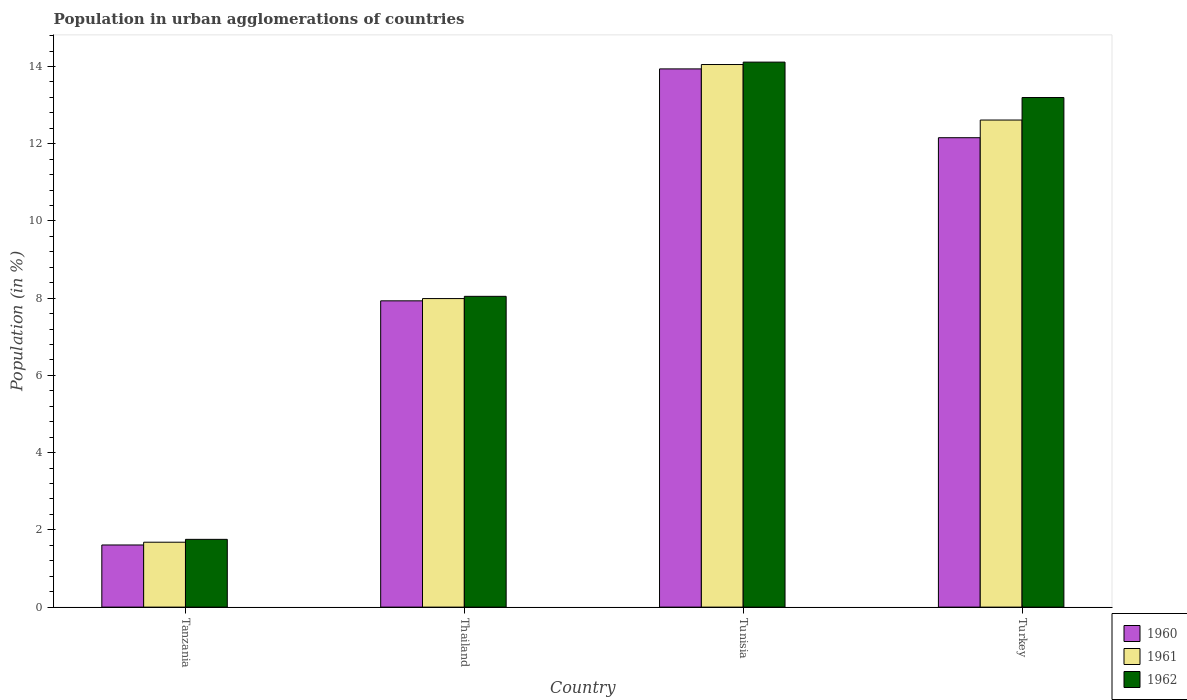How many different coloured bars are there?
Give a very brief answer. 3. How many groups of bars are there?
Provide a succinct answer. 4. Are the number of bars per tick equal to the number of legend labels?
Your answer should be very brief. Yes. What is the label of the 2nd group of bars from the left?
Offer a very short reply. Thailand. In how many cases, is the number of bars for a given country not equal to the number of legend labels?
Provide a short and direct response. 0. What is the percentage of population in urban agglomerations in 1960 in Tunisia?
Ensure brevity in your answer.  13.94. Across all countries, what is the maximum percentage of population in urban agglomerations in 1961?
Give a very brief answer. 14.05. Across all countries, what is the minimum percentage of population in urban agglomerations in 1960?
Provide a short and direct response. 1.61. In which country was the percentage of population in urban agglomerations in 1962 maximum?
Give a very brief answer. Tunisia. In which country was the percentage of population in urban agglomerations in 1961 minimum?
Your answer should be very brief. Tanzania. What is the total percentage of population in urban agglomerations in 1961 in the graph?
Provide a short and direct response. 36.34. What is the difference between the percentage of population in urban agglomerations in 1962 in Tanzania and that in Turkey?
Your answer should be compact. -11.44. What is the difference between the percentage of population in urban agglomerations in 1961 in Tanzania and the percentage of population in urban agglomerations in 1960 in Tunisia?
Keep it short and to the point. -12.26. What is the average percentage of population in urban agglomerations in 1961 per country?
Make the answer very short. 9.08. What is the difference between the percentage of population in urban agglomerations of/in 1961 and percentage of population in urban agglomerations of/in 1960 in Thailand?
Your response must be concise. 0.06. What is the ratio of the percentage of population in urban agglomerations in 1960 in Tanzania to that in Turkey?
Provide a succinct answer. 0.13. Is the percentage of population in urban agglomerations in 1960 in Thailand less than that in Tunisia?
Offer a terse response. Yes. What is the difference between the highest and the second highest percentage of population in urban agglomerations in 1960?
Keep it short and to the point. -1.78. What is the difference between the highest and the lowest percentage of population in urban agglomerations in 1962?
Give a very brief answer. 12.36. What does the 3rd bar from the left in Turkey represents?
Provide a succinct answer. 1962. Is it the case that in every country, the sum of the percentage of population in urban agglomerations in 1961 and percentage of population in urban agglomerations in 1962 is greater than the percentage of population in urban agglomerations in 1960?
Give a very brief answer. Yes. How many bars are there?
Your answer should be compact. 12. Are all the bars in the graph horizontal?
Your answer should be compact. No. Does the graph contain any zero values?
Offer a terse response. No. Does the graph contain grids?
Give a very brief answer. No. Where does the legend appear in the graph?
Make the answer very short. Bottom right. How many legend labels are there?
Make the answer very short. 3. What is the title of the graph?
Make the answer very short. Population in urban agglomerations of countries. What is the label or title of the X-axis?
Your answer should be very brief. Country. What is the Population (in %) in 1960 in Tanzania?
Provide a short and direct response. 1.61. What is the Population (in %) in 1961 in Tanzania?
Offer a very short reply. 1.68. What is the Population (in %) of 1962 in Tanzania?
Your response must be concise. 1.76. What is the Population (in %) of 1960 in Thailand?
Ensure brevity in your answer.  7.93. What is the Population (in %) in 1961 in Thailand?
Your answer should be very brief. 7.99. What is the Population (in %) of 1962 in Thailand?
Your response must be concise. 8.05. What is the Population (in %) of 1960 in Tunisia?
Your answer should be compact. 13.94. What is the Population (in %) in 1961 in Tunisia?
Keep it short and to the point. 14.05. What is the Population (in %) of 1962 in Tunisia?
Give a very brief answer. 14.11. What is the Population (in %) in 1960 in Turkey?
Your answer should be very brief. 12.16. What is the Population (in %) of 1961 in Turkey?
Keep it short and to the point. 12.61. What is the Population (in %) of 1962 in Turkey?
Give a very brief answer. 13.2. Across all countries, what is the maximum Population (in %) of 1960?
Your answer should be very brief. 13.94. Across all countries, what is the maximum Population (in %) of 1961?
Keep it short and to the point. 14.05. Across all countries, what is the maximum Population (in %) of 1962?
Offer a very short reply. 14.11. Across all countries, what is the minimum Population (in %) of 1960?
Your answer should be compact. 1.61. Across all countries, what is the minimum Population (in %) in 1961?
Offer a very short reply. 1.68. Across all countries, what is the minimum Population (in %) in 1962?
Make the answer very short. 1.76. What is the total Population (in %) of 1960 in the graph?
Offer a very short reply. 35.63. What is the total Population (in %) in 1961 in the graph?
Offer a terse response. 36.34. What is the total Population (in %) of 1962 in the graph?
Ensure brevity in your answer.  37.11. What is the difference between the Population (in %) in 1960 in Tanzania and that in Thailand?
Your response must be concise. -6.32. What is the difference between the Population (in %) of 1961 in Tanzania and that in Thailand?
Your answer should be compact. -6.31. What is the difference between the Population (in %) of 1962 in Tanzania and that in Thailand?
Provide a short and direct response. -6.29. What is the difference between the Population (in %) in 1960 in Tanzania and that in Tunisia?
Provide a succinct answer. -12.33. What is the difference between the Population (in %) in 1961 in Tanzania and that in Tunisia?
Offer a terse response. -12.37. What is the difference between the Population (in %) of 1962 in Tanzania and that in Tunisia?
Provide a succinct answer. -12.36. What is the difference between the Population (in %) in 1960 in Tanzania and that in Turkey?
Offer a terse response. -10.55. What is the difference between the Population (in %) in 1961 in Tanzania and that in Turkey?
Your answer should be very brief. -10.93. What is the difference between the Population (in %) in 1962 in Tanzania and that in Turkey?
Your response must be concise. -11.44. What is the difference between the Population (in %) of 1960 in Thailand and that in Tunisia?
Your answer should be compact. -6.01. What is the difference between the Population (in %) in 1961 in Thailand and that in Tunisia?
Your response must be concise. -6.06. What is the difference between the Population (in %) of 1962 in Thailand and that in Tunisia?
Offer a very short reply. -6.07. What is the difference between the Population (in %) in 1960 in Thailand and that in Turkey?
Give a very brief answer. -4.22. What is the difference between the Population (in %) of 1961 in Thailand and that in Turkey?
Your response must be concise. -4.62. What is the difference between the Population (in %) in 1962 in Thailand and that in Turkey?
Offer a very short reply. -5.15. What is the difference between the Population (in %) in 1960 in Tunisia and that in Turkey?
Your answer should be very brief. 1.78. What is the difference between the Population (in %) in 1961 in Tunisia and that in Turkey?
Offer a very short reply. 1.44. What is the difference between the Population (in %) in 1960 in Tanzania and the Population (in %) in 1961 in Thailand?
Make the answer very short. -6.38. What is the difference between the Population (in %) in 1960 in Tanzania and the Population (in %) in 1962 in Thailand?
Your answer should be compact. -6.44. What is the difference between the Population (in %) of 1961 in Tanzania and the Population (in %) of 1962 in Thailand?
Offer a terse response. -6.37. What is the difference between the Population (in %) in 1960 in Tanzania and the Population (in %) in 1961 in Tunisia?
Ensure brevity in your answer.  -12.44. What is the difference between the Population (in %) in 1960 in Tanzania and the Population (in %) in 1962 in Tunisia?
Make the answer very short. -12.5. What is the difference between the Population (in %) in 1961 in Tanzania and the Population (in %) in 1962 in Tunisia?
Your response must be concise. -12.43. What is the difference between the Population (in %) in 1960 in Tanzania and the Population (in %) in 1961 in Turkey?
Your answer should be very brief. -11. What is the difference between the Population (in %) in 1960 in Tanzania and the Population (in %) in 1962 in Turkey?
Provide a short and direct response. -11.59. What is the difference between the Population (in %) of 1961 in Tanzania and the Population (in %) of 1962 in Turkey?
Ensure brevity in your answer.  -11.52. What is the difference between the Population (in %) in 1960 in Thailand and the Population (in %) in 1961 in Tunisia?
Your answer should be compact. -6.12. What is the difference between the Population (in %) of 1960 in Thailand and the Population (in %) of 1962 in Tunisia?
Your answer should be very brief. -6.18. What is the difference between the Population (in %) of 1961 in Thailand and the Population (in %) of 1962 in Tunisia?
Provide a short and direct response. -6.12. What is the difference between the Population (in %) in 1960 in Thailand and the Population (in %) in 1961 in Turkey?
Make the answer very short. -4.68. What is the difference between the Population (in %) in 1960 in Thailand and the Population (in %) in 1962 in Turkey?
Your answer should be compact. -5.27. What is the difference between the Population (in %) of 1961 in Thailand and the Population (in %) of 1962 in Turkey?
Keep it short and to the point. -5.21. What is the difference between the Population (in %) in 1960 in Tunisia and the Population (in %) in 1961 in Turkey?
Your answer should be compact. 1.32. What is the difference between the Population (in %) in 1960 in Tunisia and the Population (in %) in 1962 in Turkey?
Your answer should be very brief. 0.74. What is the difference between the Population (in %) of 1961 in Tunisia and the Population (in %) of 1962 in Turkey?
Provide a succinct answer. 0.85. What is the average Population (in %) in 1960 per country?
Offer a very short reply. 8.91. What is the average Population (in %) of 1961 per country?
Provide a succinct answer. 9.08. What is the average Population (in %) of 1962 per country?
Provide a short and direct response. 9.28. What is the difference between the Population (in %) in 1960 and Population (in %) in 1961 in Tanzania?
Offer a terse response. -0.07. What is the difference between the Population (in %) of 1960 and Population (in %) of 1962 in Tanzania?
Provide a short and direct response. -0.15. What is the difference between the Population (in %) of 1961 and Population (in %) of 1962 in Tanzania?
Offer a very short reply. -0.07. What is the difference between the Population (in %) of 1960 and Population (in %) of 1961 in Thailand?
Ensure brevity in your answer.  -0.06. What is the difference between the Population (in %) in 1960 and Population (in %) in 1962 in Thailand?
Give a very brief answer. -0.12. What is the difference between the Population (in %) of 1961 and Population (in %) of 1962 in Thailand?
Make the answer very short. -0.06. What is the difference between the Population (in %) in 1960 and Population (in %) in 1961 in Tunisia?
Make the answer very short. -0.11. What is the difference between the Population (in %) of 1960 and Population (in %) of 1962 in Tunisia?
Keep it short and to the point. -0.18. What is the difference between the Population (in %) in 1961 and Population (in %) in 1962 in Tunisia?
Provide a short and direct response. -0.06. What is the difference between the Population (in %) of 1960 and Population (in %) of 1961 in Turkey?
Your response must be concise. -0.46. What is the difference between the Population (in %) in 1960 and Population (in %) in 1962 in Turkey?
Your answer should be compact. -1.04. What is the difference between the Population (in %) in 1961 and Population (in %) in 1962 in Turkey?
Provide a short and direct response. -0.58. What is the ratio of the Population (in %) of 1960 in Tanzania to that in Thailand?
Provide a succinct answer. 0.2. What is the ratio of the Population (in %) of 1961 in Tanzania to that in Thailand?
Provide a short and direct response. 0.21. What is the ratio of the Population (in %) in 1962 in Tanzania to that in Thailand?
Your answer should be compact. 0.22. What is the ratio of the Population (in %) in 1960 in Tanzania to that in Tunisia?
Offer a very short reply. 0.12. What is the ratio of the Population (in %) of 1961 in Tanzania to that in Tunisia?
Your answer should be very brief. 0.12. What is the ratio of the Population (in %) in 1962 in Tanzania to that in Tunisia?
Provide a short and direct response. 0.12. What is the ratio of the Population (in %) in 1960 in Tanzania to that in Turkey?
Your answer should be compact. 0.13. What is the ratio of the Population (in %) in 1961 in Tanzania to that in Turkey?
Your answer should be compact. 0.13. What is the ratio of the Population (in %) of 1962 in Tanzania to that in Turkey?
Offer a very short reply. 0.13. What is the ratio of the Population (in %) of 1960 in Thailand to that in Tunisia?
Offer a terse response. 0.57. What is the ratio of the Population (in %) in 1961 in Thailand to that in Tunisia?
Your answer should be very brief. 0.57. What is the ratio of the Population (in %) in 1962 in Thailand to that in Tunisia?
Offer a terse response. 0.57. What is the ratio of the Population (in %) in 1960 in Thailand to that in Turkey?
Offer a terse response. 0.65. What is the ratio of the Population (in %) of 1961 in Thailand to that in Turkey?
Your response must be concise. 0.63. What is the ratio of the Population (in %) of 1962 in Thailand to that in Turkey?
Offer a very short reply. 0.61. What is the ratio of the Population (in %) in 1960 in Tunisia to that in Turkey?
Your answer should be very brief. 1.15. What is the ratio of the Population (in %) in 1961 in Tunisia to that in Turkey?
Provide a short and direct response. 1.11. What is the ratio of the Population (in %) of 1962 in Tunisia to that in Turkey?
Offer a terse response. 1.07. What is the difference between the highest and the second highest Population (in %) in 1960?
Your answer should be compact. 1.78. What is the difference between the highest and the second highest Population (in %) in 1961?
Ensure brevity in your answer.  1.44. What is the difference between the highest and the second highest Population (in %) of 1962?
Your answer should be very brief. 0.92. What is the difference between the highest and the lowest Population (in %) of 1960?
Offer a very short reply. 12.33. What is the difference between the highest and the lowest Population (in %) in 1961?
Provide a short and direct response. 12.37. What is the difference between the highest and the lowest Population (in %) of 1962?
Make the answer very short. 12.36. 